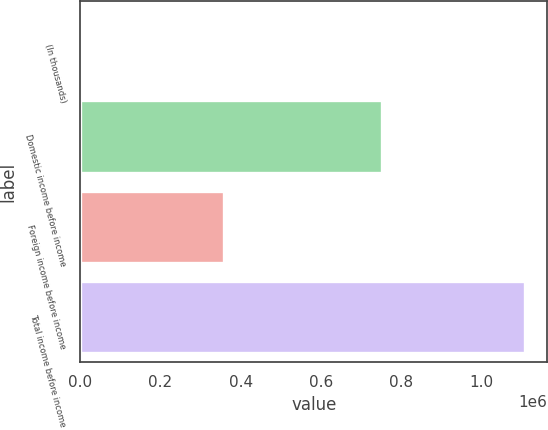Convert chart. <chart><loc_0><loc_0><loc_500><loc_500><bar_chart><fcel>(In thousands)<fcel>Domestic income before income<fcel>Foreign income before income<fcel>Total income before income<nl><fcel>2011<fcel>752163<fcel>357903<fcel>1.11007e+06<nl></chart> 